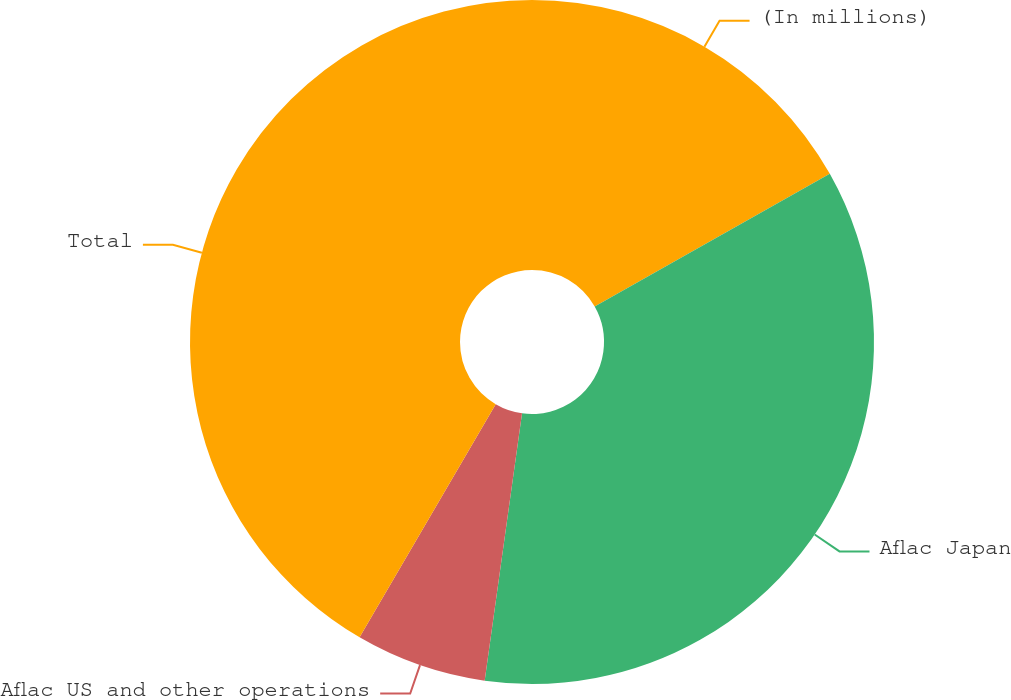<chart> <loc_0><loc_0><loc_500><loc_500><pie_chart><fcel>(In millions)<fcel>Aflac Japan<fcel>Aflac US and other operations<fcel>Total<nl><fcel>16.82%<fcel>35.39%<fcel>6.2%<fcel>41.59%<nl></chart> 